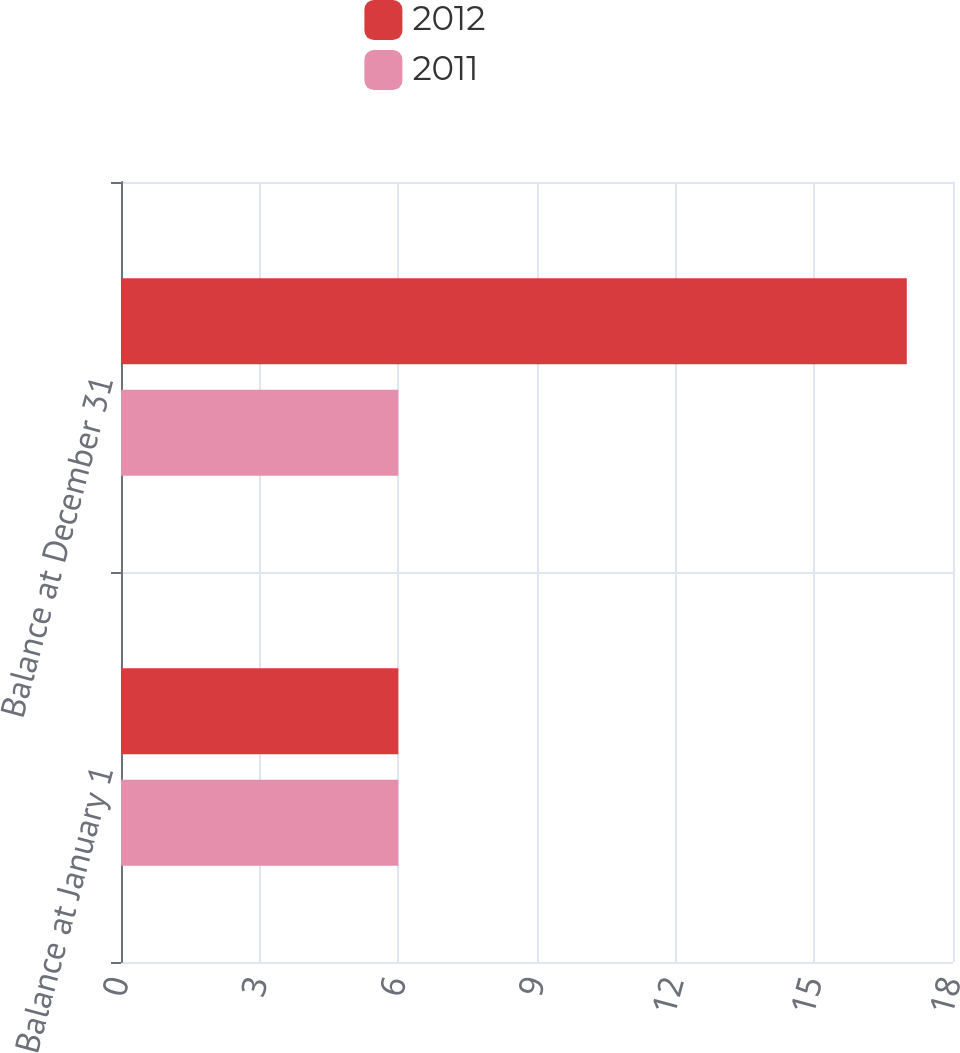<chart> <loc_0><loc_0><loc_500><loc_500><stacked_bar_chart><ecel><fcel>Balance at January 1<fcel>Balance at December 31<nl><fcel>2012<fcel>6<fcel>17<nl><fcel>2011<fcel>6<fcel>6<nl></chart> 